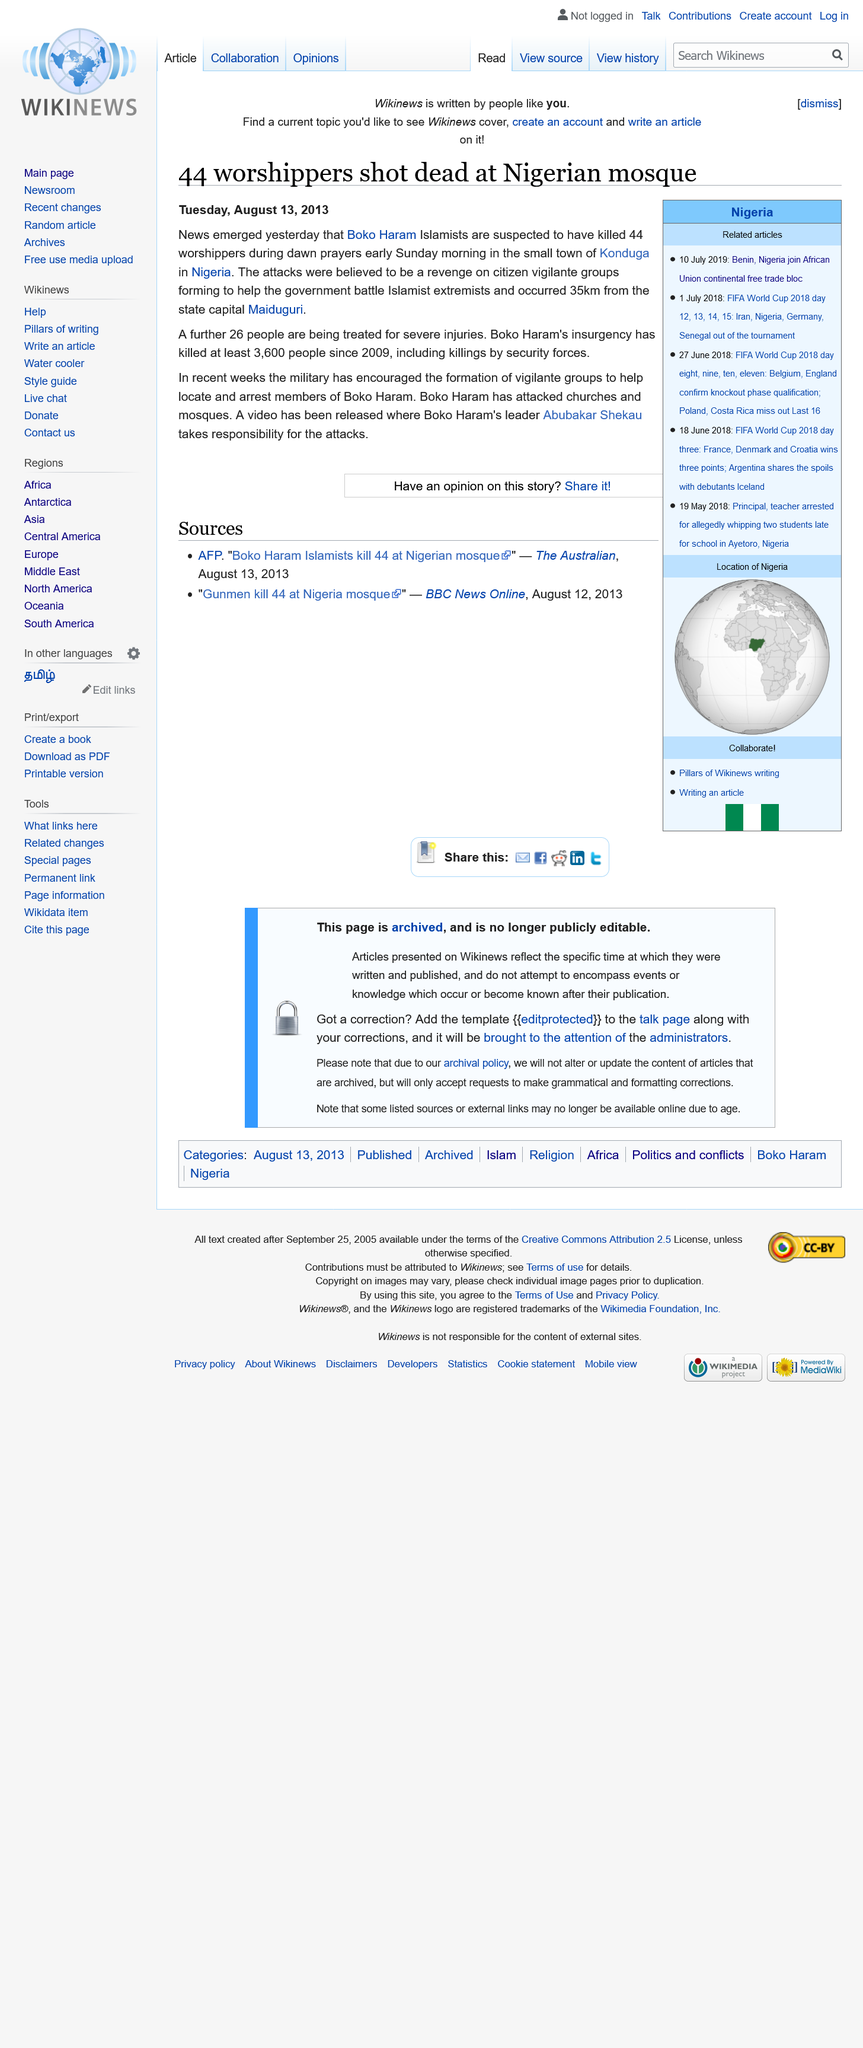Draw attention to some important aspects in this diagram. In the attack, 44 people were killed and 26 were injured. The attack took place in the small town of Konduga. Boko Haram is believed to be responsible for the attack. 